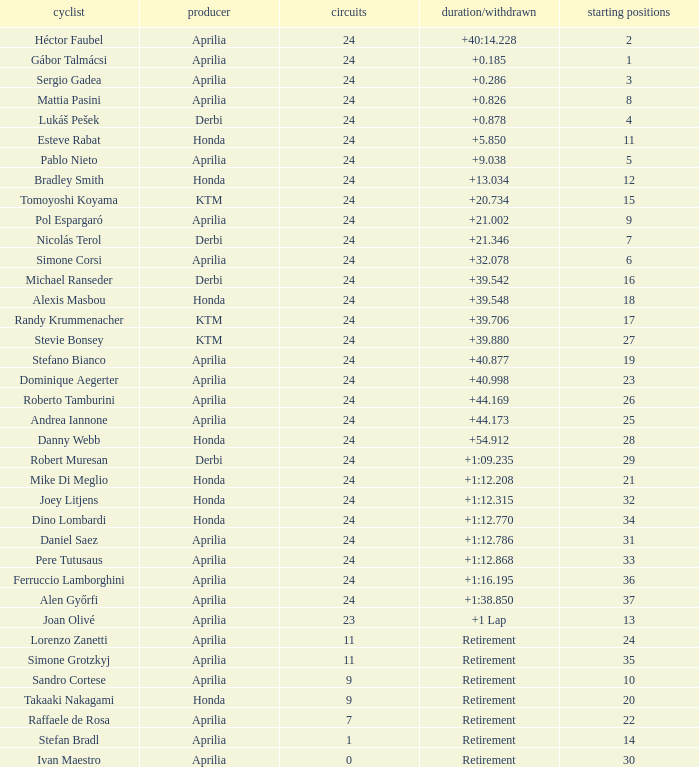How many grids have more than 24 laps with a time/retired of +1:12.208? None. 